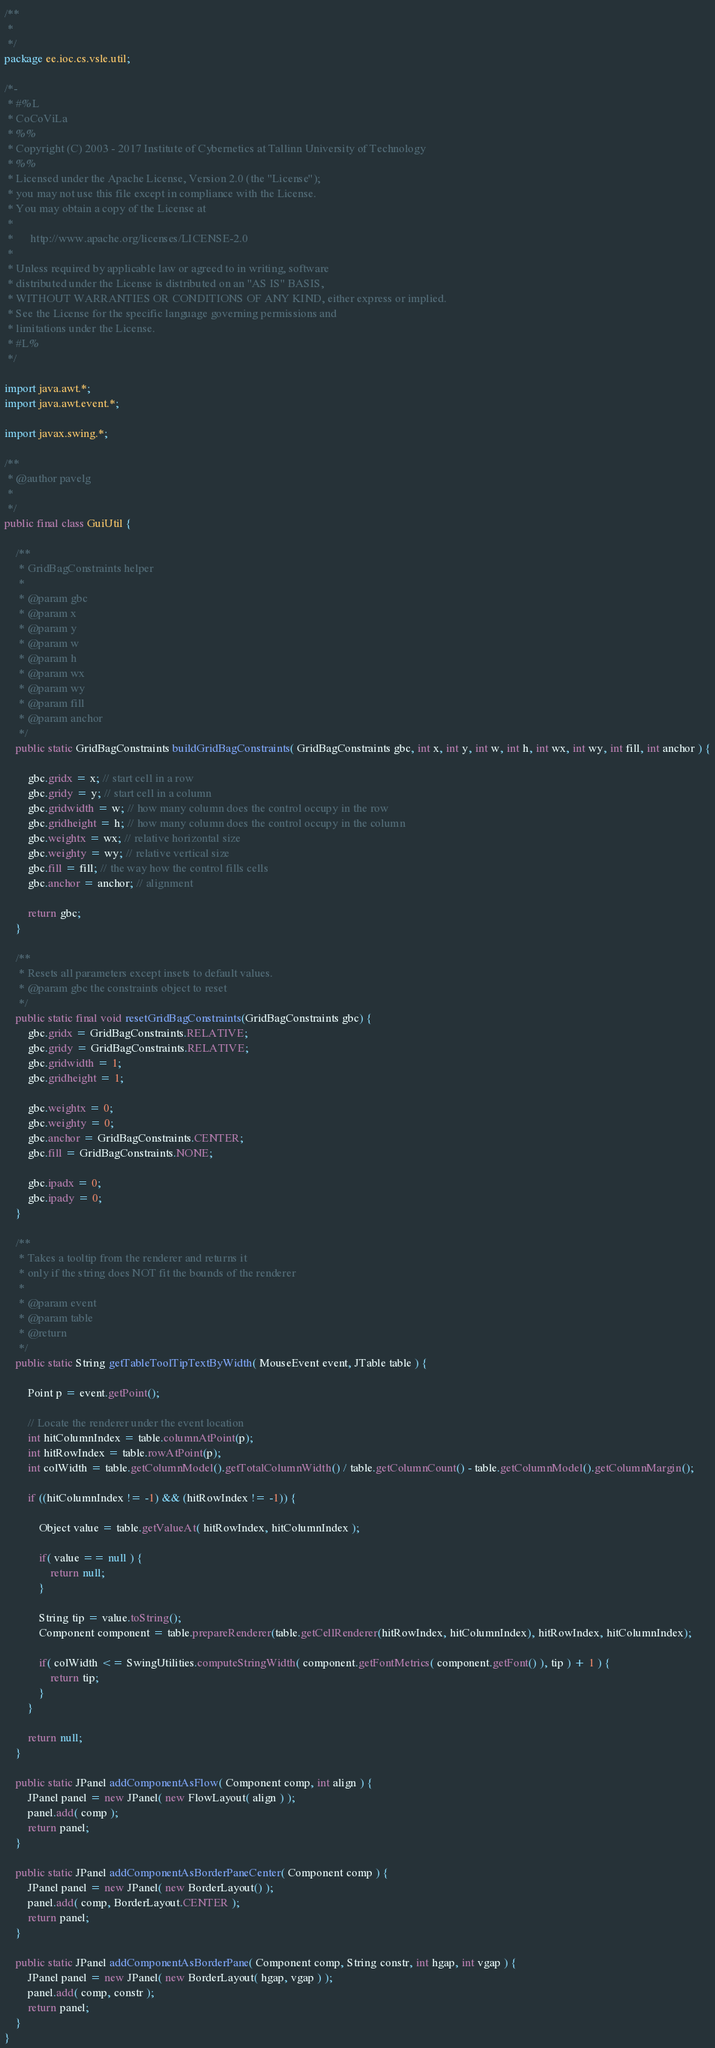Convert code to text. <code><loc_0><loc_0><loc_500><loc_500><_Java_>/**
 * 
 */
package ee.ioc.cs.vsle.util;

/*-
 * #%L
 * CoCoViLa
 * %%
 * Copyright (C) 2003 - 2017 Institute of Cybernetics at Tallinn University of Technology
 * %%
 * Licensed under the Apache License, Version 2.0 (the "License");
 * you may not use this file except in compliance with the License.
 * You may obtain a copy of the License at
 * 
 *      http://www.apache.org/licenses/LICENSE-2.0
 * 
 * Unless required by applicable law or agreed to in writing, software
 * distributed under the License is distributed on an "AS IS" BASIS,
 * WITHOUT WARRANTIES OR CONDITIONS OF ANY KIND, either express or implied.
 * See the License for the specific language governing permissions and
 * limitations under the License.
 * #L%
 */

import java.awt.*;
import java.awt.event.*;

import javax.swing.*;

/**
 * @author pavelg
 *
 */
public final class GuiUtil {

    /**
     * GridBagConstraints helper
     * 
     * @param gbc
     * @param x
     * @param y
     * @param w
     * @param h
     * @param wx
     * @param wy
     * @param fill
     * @param anchor
     */
    public static GridBagConstraints buildGridBagConstraints( GridBagConstraints gbc, int x, int y, int w, int h, int wx, int wy, int fill, int anchor ) {

        gbc.gridx = x; // start cell in a row
        gbc.gridy = y; // start cell in a column
        gbc.gridwidth = w; // how many column does the control occupy in the row
        gbc.gridheight = h; // how many column does the control occupy in the column
        gbc.weightx = wx; // relative horizontal size
        gbc.weighty = wy; // relative vertical size
        gbc.fill = fill; // the way how the control fills cells
        gbc.anchor = anchor; // alignment

        return gbc;
    }

    /**
     * Resets all parameters except insets to default values.
     * @param gbc the constraints object to reset
     */
    public static final void resetGridBagConstraints(GridBagConstraints gbc) {
        gbc.gridx = GridBagConstraints.RELATIVE;
        gbc.gridy = GridBagConstraints.RELATIVE;
        gbc.gridwidth = 1;
        gbc.gridheight = 1;

        gbc.weightx = 0;
        gbc.weighty = 0;
        gbc.anchor = GridBagConstraints.CENTER;
        gbc.fill = GridBagConstraints.NONE;

        gbc.ipadx = 0;
        gbc.ipady = 0;
    }

    /**
     * Takes a tooltip from the renderer and returns it 
     * only if the string does NOT fit the bounds of the renderer
     * 
     * @param event
     * @param table
     * @return
     */
    public static String getTableToolTipTextByWidth( MouseEvent event, JTable table ) {
        
        Point p = event.getPoint();

        // Locate the renderer under the event location
        int hitColumnIndex = table.columnAtPoint(p);
        int hitRowIndex = table.rowAtPoint(p);
        int colWidth = table.getColumnModel().getTotalColumnWidth() / table.getColumnCount() - table.getColumnModel().getColumnMargin();
        
        if ((hitColumnIndex != -1) && (hitRowIndex != -1)) {
            
            Object value = table.getValueAt( hitRowIndex, hitColumnIndex );
            
            if( value == null ) {
                return null;
            }
            
            String tip = value.toString();
            Component component = table.prepareRenderer(table.getCellRenderer(hitRowIndex, hitColumnIndex), hitRowIndex, hitColumnIndex);

            if( colWidth <= SwingUtilities.computeStringWidth( component.getFontMetrics( component.getFont() ), tip ) + 1 ) {
                return tip;
            }
        }
        
        return null;
    }
    
    public static JPanel addComponentAsFlow( Component comp, int align ) {
        JPanel panel = new JPanel( new FlowLayout( align ) );
        panel.add( comp );
        return panel;
    }
    
    public static JPanel addComponentAsBorderPaneCenter( Component comp ) {
        JPanel panel = new JPanel( new BorderLayout() );
        panel.add( comp, BorderLayout.CENTER );
        return panel;
    }
    
    public static JPanel addComponentAsBorderPane( Component comp, String constr, int hgap, int vgap ) {
        JPanel panel = new JPanel( new BorderLayout( hgap, vgap ) );
        panel.add( comp, constr );
        return panel;
    }
}
</code> 